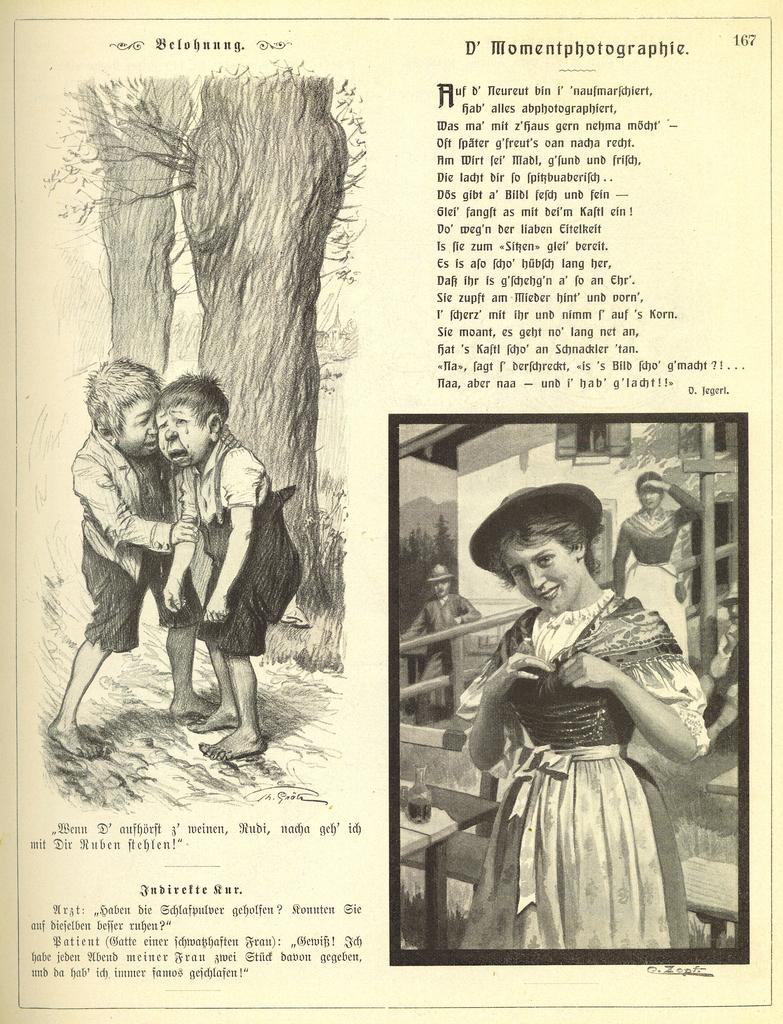What is present on the paper in the image? The paper contains a passage. Where is the girl located in the image? The girl is at the right bottom of the image. How many people are on the left side of the image? There are two persons on the left side of the image. What can be seen on the left side of the image besides the people? There is a tree on the left side of the image. What type of whip is being traded by the girl in the image? There is no whip present in the image, nor is there any indication of a trade taking place. 